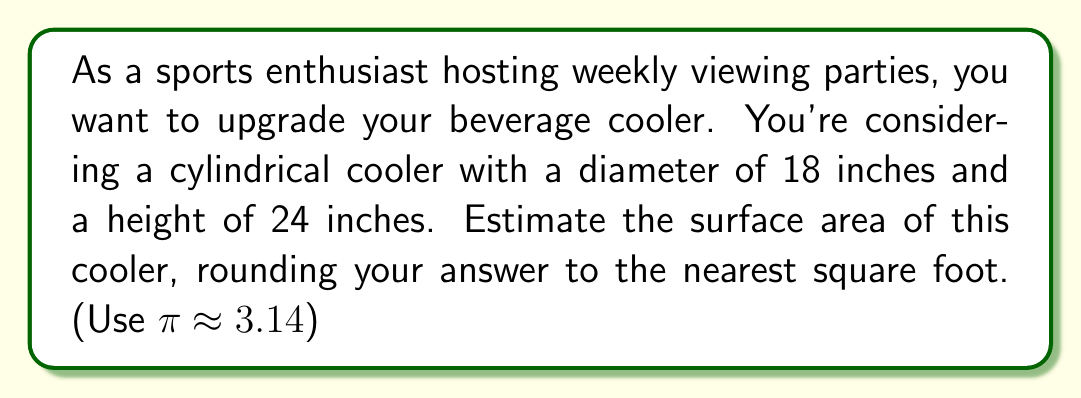Give your solution to this math problem. Let's approach this step-by-step:

1) The surface area of a cylinder consists of two circular bases and the lateral area (side).

2) For the circular bases:
   - Radius $r = \frac{\text{diameter}}{2} = \frac{18}{2} = 9$ inches
   - Area of one base: $A_b = \pi r^2 = \pi (9^2) = 81\pi$ sq inches
   - Area of both bases: $2(81\pi) = 162\pi$ sq inches

3) For the lateral area:
   - Circumference of the base: $C = 2\pi r = 2\pi(9) = 18\pi$ inches
   - Height: $h = 24$ inches
   - Lateral area: $A_l = Ch = 18\pi(24) = 432\pi$ sq inches

4) Total surface area:
   $$ A_{\text{total}} = 2A_b + A_l = 162\pi + 432\pi = 594\pi \text{ sq inches} $$

5) Converting to square feet:
   $$ A_{\text{total}} = 594\pi \cdot \frac{1 \text{ sq ft}}{144 \text{ sq inches}} \approx 12.95 \text{ sq ft} $$

6) Rounding to the nearest square foot:
   $12.95 \text{ sq ft} \approx 13 \text{ sq ft}$

[asy]
import geometry;

real r = 1;
real h = 4/3;
path3 p = circle((0,0,0),r);
path3 q = circle((0,0,h),r);
surface cylSurf = surface(p--q--cycle);
draw(cylSurf,paleblue+opacity(0.5));
draw(p);
draw(q);
draw((r,0,0)--(r,0,h));
draw((0,r,0)--(0,r,h));
draw((-r,0,0)--(-r,0,h));
draw((0,-r,0)--(0,-r,h));
label("r", (r/2,0,0), E);
label("h", (r,0,h/2), E);

camera.perspective = false;
camera.view((4,2,2));
[/asy]
Answer: $13 \text{ sq ft}$ 